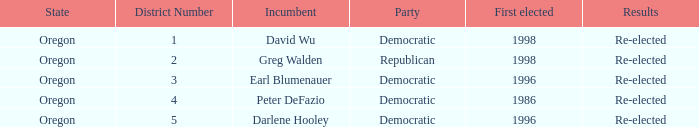Who is the incumbent for the Oregon 5 District that was elected in 1996? Darlene Hooley. 